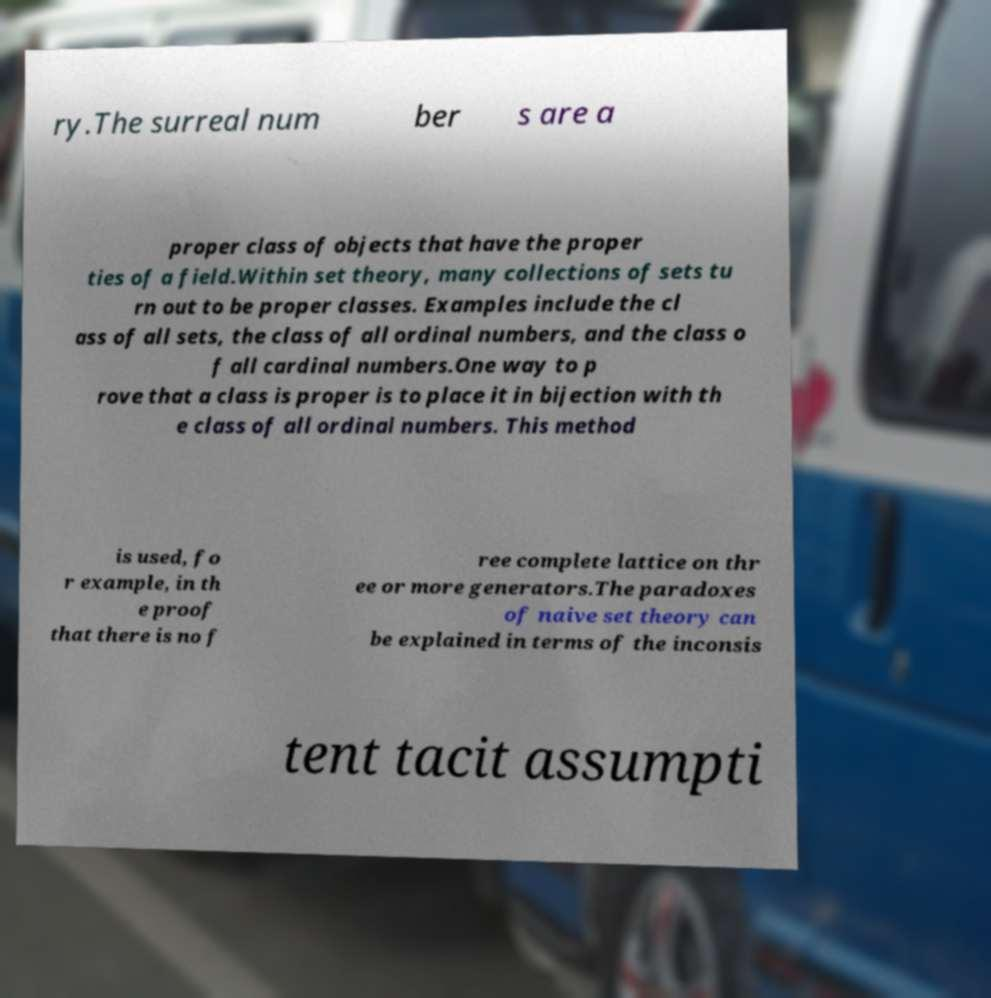Can you read and provide the text displayed in the image?This photo seems to have some interesting text. Can you extract and type it out for me? ry.The surreal num ber s are a proper class of objects that have the proper ties of a field.Within set theory, many collections of sets tu rn out to be proper classes. Examples include the cl ass of all sets, the class of all ordinal numbers, and the class o f all cardinal numbers.One way to p rove that a class is proper is to place it in bijection with th e class of all ordinal numbers. This method is used, fo r example, in th e proof that there is no f ree complete lattice on thr ee or more generators.The paradoxes of naive set theory can be explained in terms of the inconsis tent tacit assumpti 